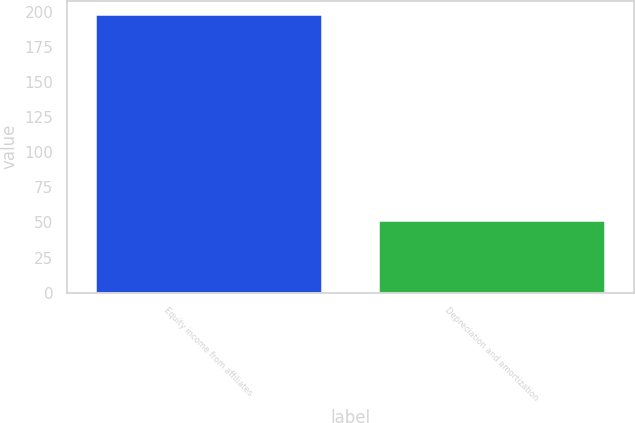Convert chart. <chart><loc_0><loc_0><loc_500><loc_500><bar_chart><fcel>Equity income from affiliates<fcel>Depreciation and amortization<nl><fcel>198<fcel>52<nl></chart> 